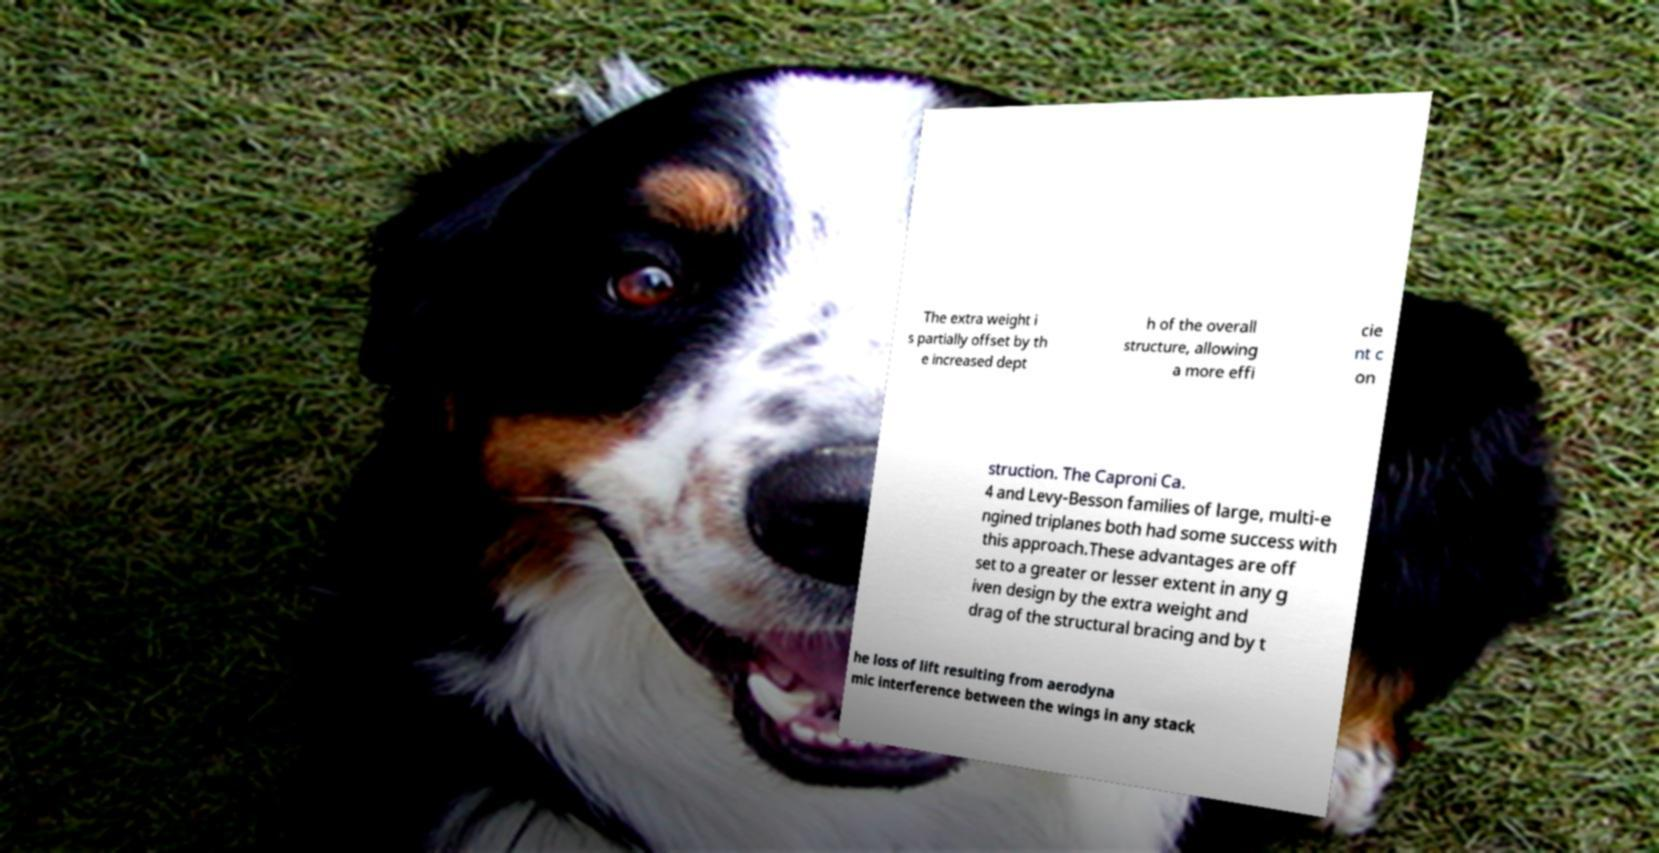I need the written content from this picture converted into text. Can you do that? The extra weight i s partially offset by th e increased dept h of the overall structure, allowing a more effi cie nt c on struction. The Caproni Ca. 4 and Levy-Besson families of large, multi-e ngined triplanes both had some success with this approach.These advantages are off set to a greater or lesser extent in any g iven design by the extra weight and drag of the structural bracing and by t he loss of lift resulting from aerodyna mic interference between the wings in any stack 